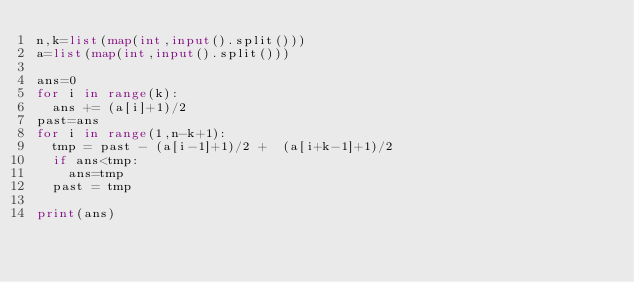<code> <loc_0><loc_0><loc_500><loc_500><_Python_>n,k=list(map(int,input().split()))
a=list(map(int,input().split()))
  
ans=0
for i in range(k):
  ans += (a[i]+1)/2
past=ans
for i in range(1,n-k+1):
  tmp = past - (a[i-1]+1)/2 +  (a[i+k-1]+1)/2
  if ans<tmp:
    ans=tmp
  past = tmp
    
print(ans)</code> 